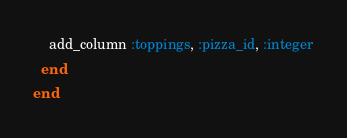Convert code to text. <code><loc_0><loc_0><loc_500><loc_500><_Ruby_>    add_column :toppings, :pizza_id, :integer
  end
end
</code> 